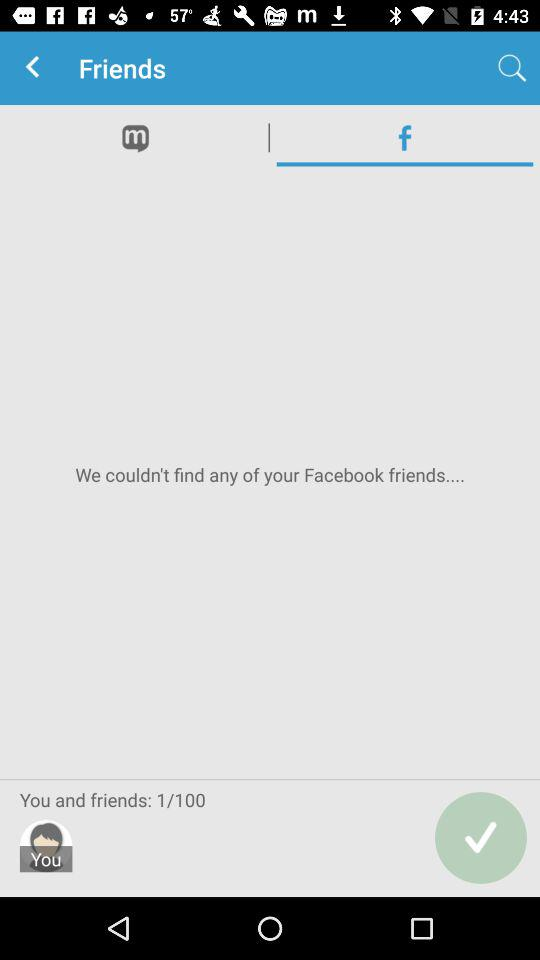How many more friends do you need to reach 100%?
Answer the question using a single word or phrase. 99 